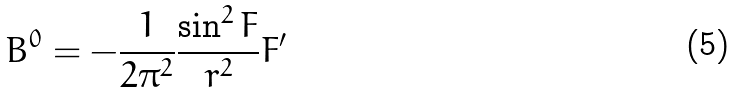Convert formula to latex. <formula><loc_0><loc_0><loc_500><loc_500>B ^ { 0 } = - \frac { 1 } { 2 \pi ^ { 2 } } \frac { \sin ^ { 2 } F } { r ^ { 2 } } F ^ { \prime }</formula> 